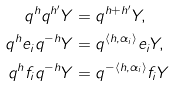<formula> <loc_0><loc_0><loc_500><loc_500>q ^ { h } q ^ { h ^ { \prime } } Y & = q ^ { h + h ^ { \prime } } Y , \\ q ^ { h } e _ { i } q ^ { - h } Y & = q ^ { \langle h , \alpha _ { i } \rangle } e _ { i } Y , \\ q ^ { h } f _ { i } q ^ { - h } Y & = q ^ { - \langle h , \alpha _ { i } \rangle } f _ { i } Y</formula> 